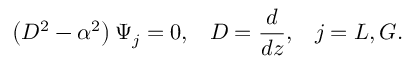<formula> <loc_0><loc_0><loc_500><loc_500>\left ( D ^ { 2 } - \alpha ^ { 2 } \right ) \Psi _ { j } = 0 , \, \ D = { \frac { d } { d z } } , \, \ j = L , G .</formula> 